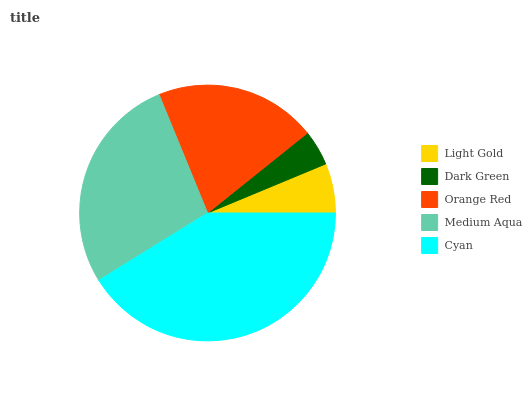Is Dark Green the minimum?
Answer yes or no. Yes. Is Cyan the maximum?
Answer yes or no. Yes. Is Orange Red the minimum?
Answer yes or no. No. Is Orange Red the maximum?
Answer yes or no. No. Is Orange Red greater than Dark Green?
Answer yes or no. Yes. Is Dark Green less than Orange Red?
Answer yes or no. Yes. Is Dark Green greater than Orange Red?
Answer yes or no. No. Is Orange Red less than Dark Green?
Answer yes or no. No. Is Orange Red the high median?
Answer yes or no. Yes. Is Orange Red the low median?
Answer yes or no. Yes. Is Medium Aqua the high median?
Answer yes or no. No. Is Medium Aqua the low median?
Answer yes or no. No. 